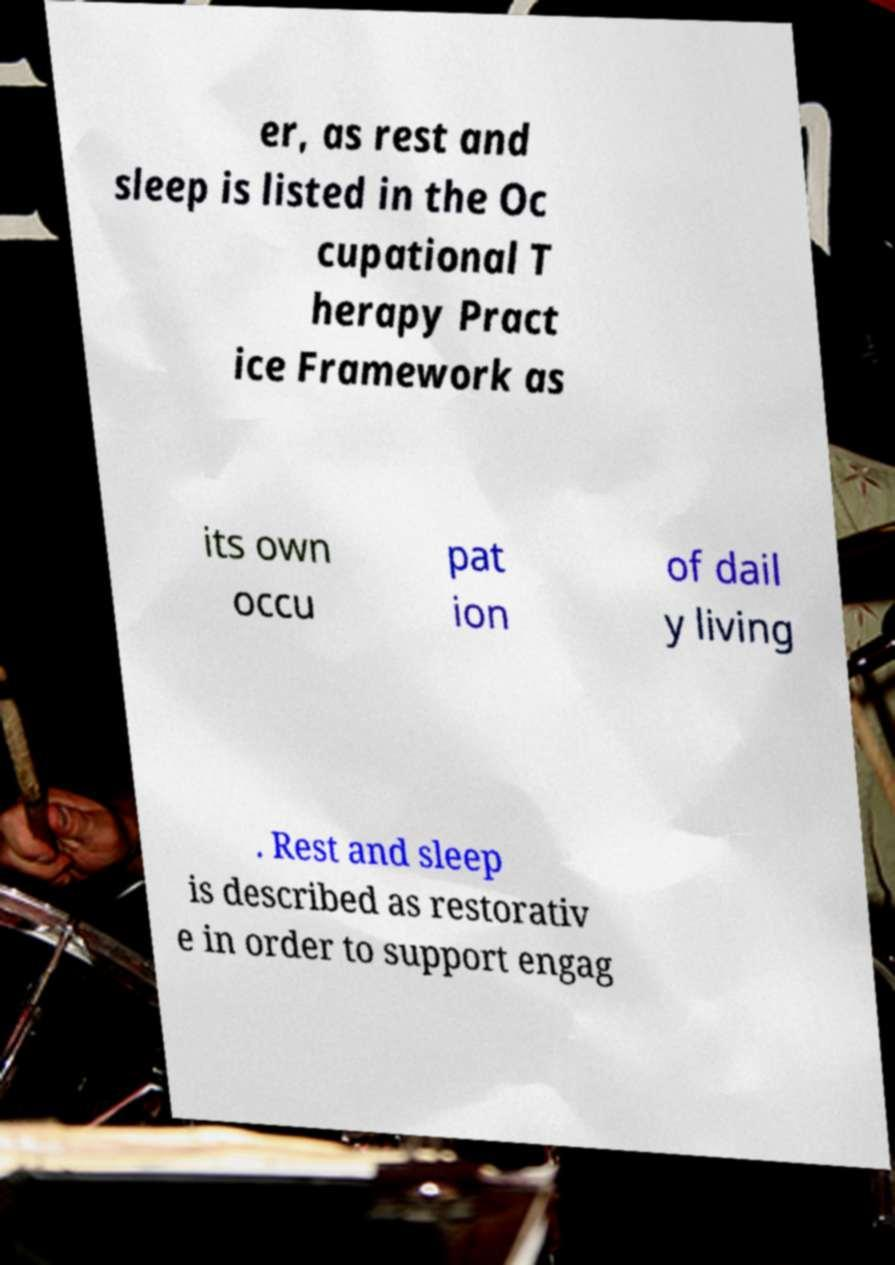For documentation purposes, I need the text within this image transcribed. Could you provide that? er, as rest and sleep is listed in the Oc cupational T herapy Pract ice Framework as its own occu pat ion of dail y living . Rest and sleep is described as restorativ e in order to support engag 